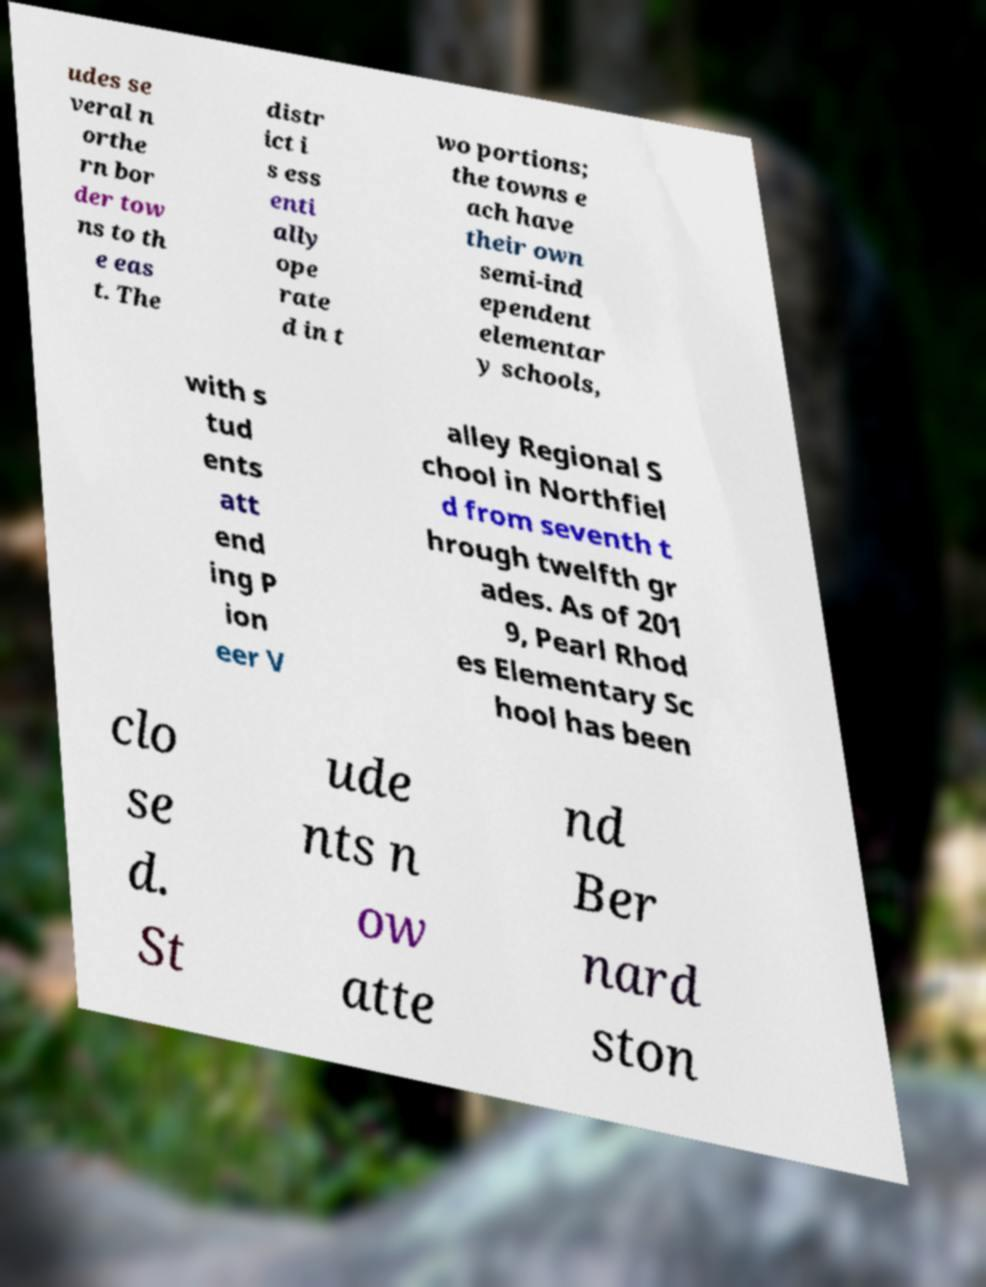Could you assist in decoding the text presented in this image and type it out clearly? udes se veral n orthe rn bor der tow ns to th e eas t. The distr ict i s ess enti ally ope rate d in t wo portions; the towns e ach have their own semi-ind ependent elementar y schools, with s tud ents att end ing P ion eer V alley Regional S chool in Northfiel d from seventh t hrough twelfth gr ades. As of 201 9, Pearl Rhod es Elementary Sc hool has been clo se d. St ude nts n ow atte nd Ber nard ston 